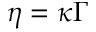Convert formula to latex. <formula><loc_0><loc_0><loc_500><loc_500>\eta = \kappa \Gamma</formula> 